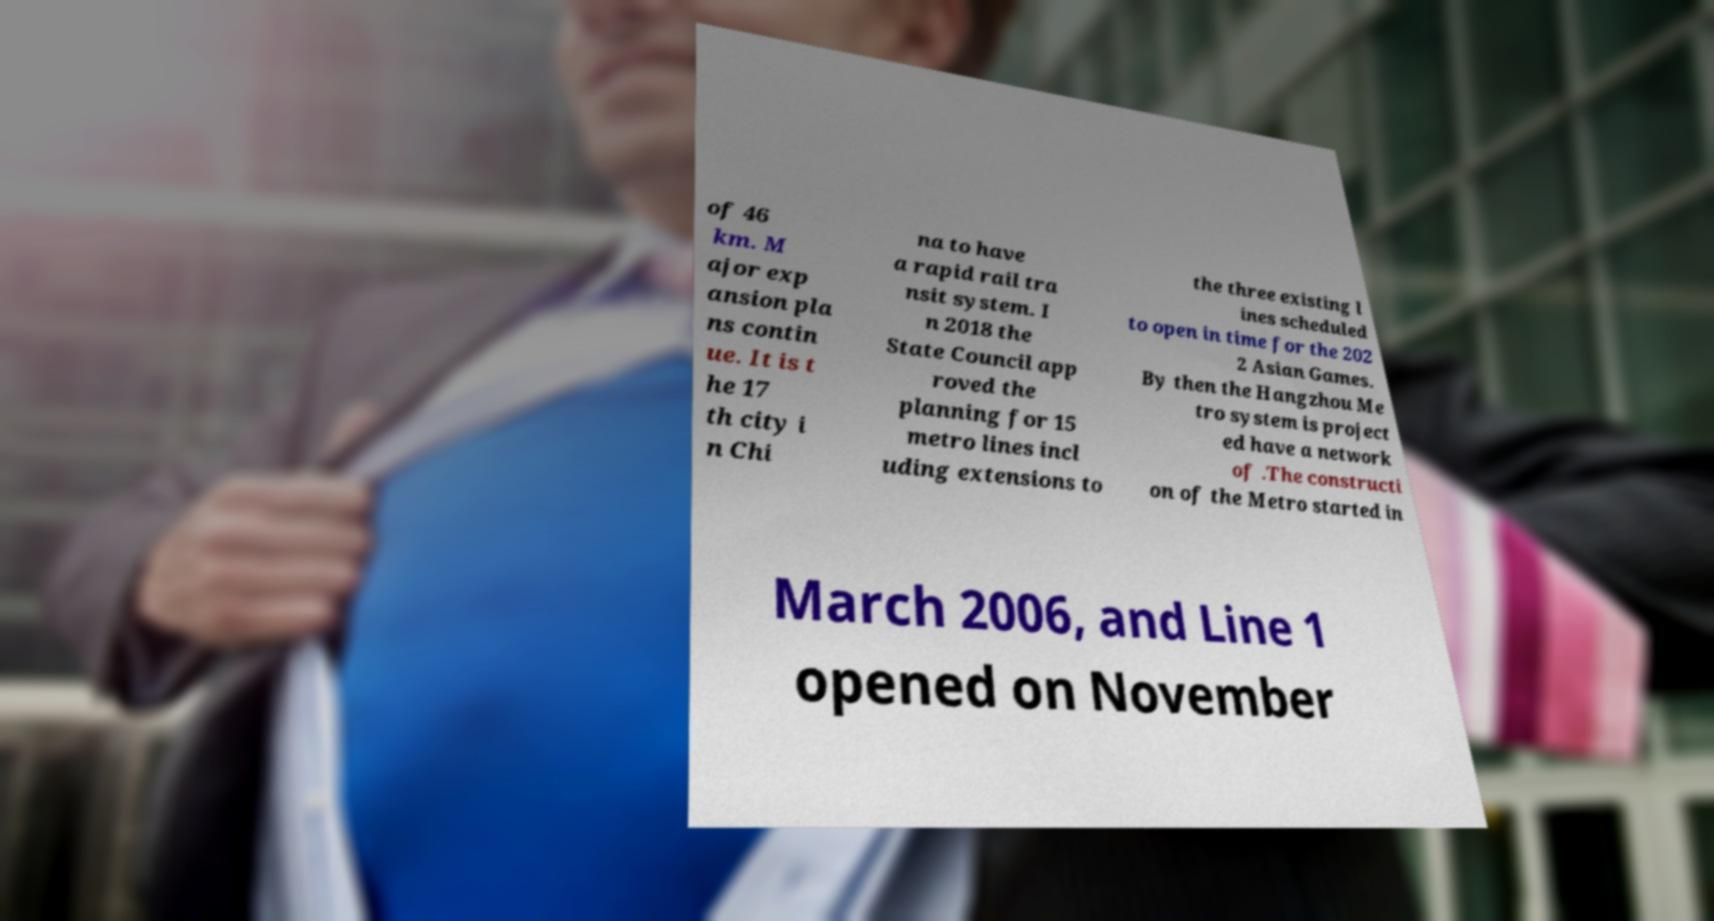Please read and relay the text visible in this image. What does it say? of 46 km. M ajor exp ansion pla ns contin ue. It is t he 17 th city i n Chi na to have a rapid rail tra nsit system. I n 2018 the State Council app roved the planning for 15 metro lines incl uding extensions to the three existing l ines scheduled to open in time for the 202 2 Asian Games. By then the Hangzhou Me tro system is project ed have a network of .The constructi on of the Metro started in March 2006, and Line 1 opened on November 